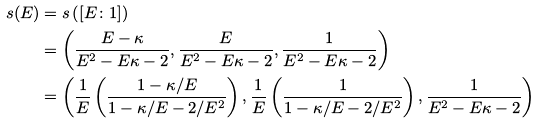<formula> <loc_0><loc_0><loc_500><loc_500>s ( E ) & = s \left ( [ E \colon 1 ] \right ) \\ & = \left ( \frac { E - \kappa } { E ^ { 2 } - E \kappa - 2 } , \frac { E } { E ^ { 2 } - E \kappa - 2 } , \frac { 1 } { E ^ { 2 } - E \kappa - 2 } \right ) \\ & = \left ( \frac { 1 } { E } \left ( \frac { 1 - \kappa / E } { 1 - \kappa / E - 2 / E ^ { 2 } } \right ) , \frac { 1 } { E } \left ( \frac { 1 } { 1 - \kappa / E - 2 / E ^ { 2 } } \right ) , \frac { 1 } { E ^ { 2 } - E \kappa - 2 } \right )</formula> 